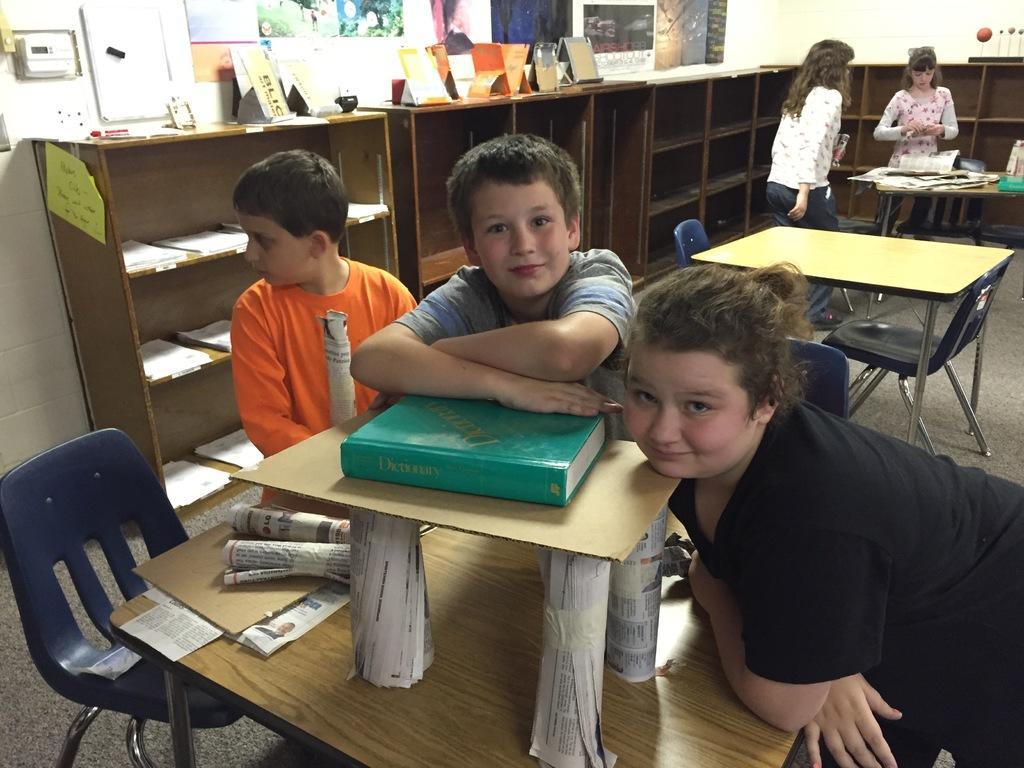Please provide a concise description of this image. people are resting on the table. on the table there are papers and book. behind them there are shelves. at the back there are 2 girls standing. on the left , photos are attached to the wall. 